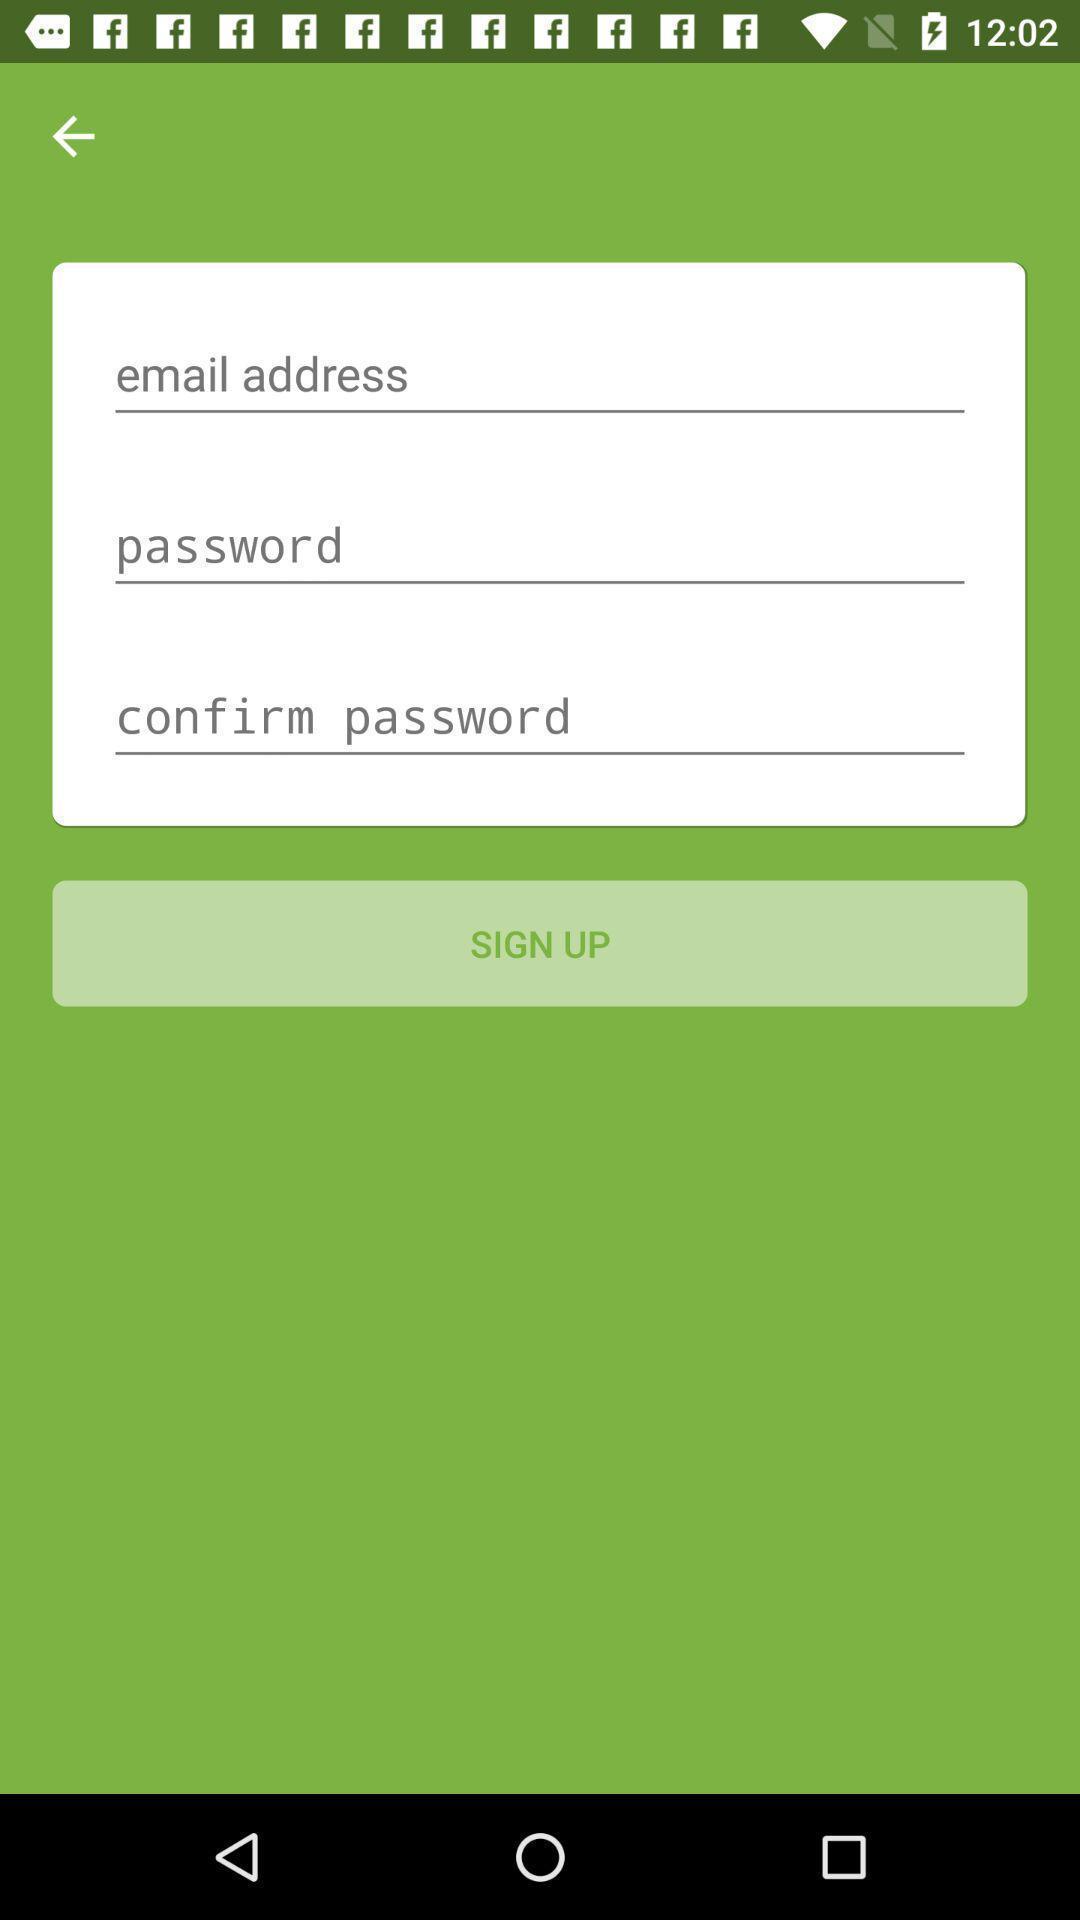Tell me what you see in this picture. Sign-up page is displaying. 